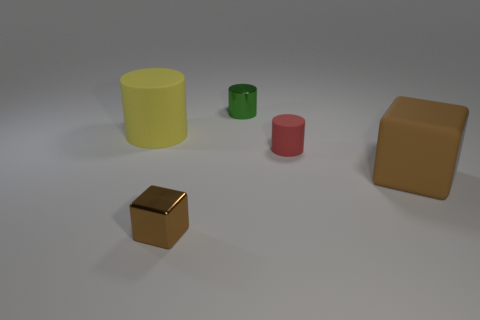The yellow rubber thing is what size?
Your response must be concise. Large. There is a rubber block that is the same size as the yellow matte thing; what color is it?
Your answer should be compact. Brown. Is there a large cylinder of the same color as the metal block?
Keep it short and to the point. No. What is the material of the tiny brown cube?
Keep it short and to the point. Metal. How many big green objects are there?
Keep it short and to the point. 0. There is a cube that is on the left side of the big brown rubber block; is its color the same as the cylinder that is to the right of the small green metallic cylinder?
Offer a terse response. No. What size is the thing that is the same color as the tiny block?
Ensure brevity in your answer.  Large. What number of other things are the same size as the yellow thing?
Offer a very short reply. 1. There is a shiny thing behind the matte cube; what is its color?
Provide a short and direct response. Green. Is the material of the cube that is in front of the big matte block the same as the large cylinder?
Ensure brevity in your answer.  No. 